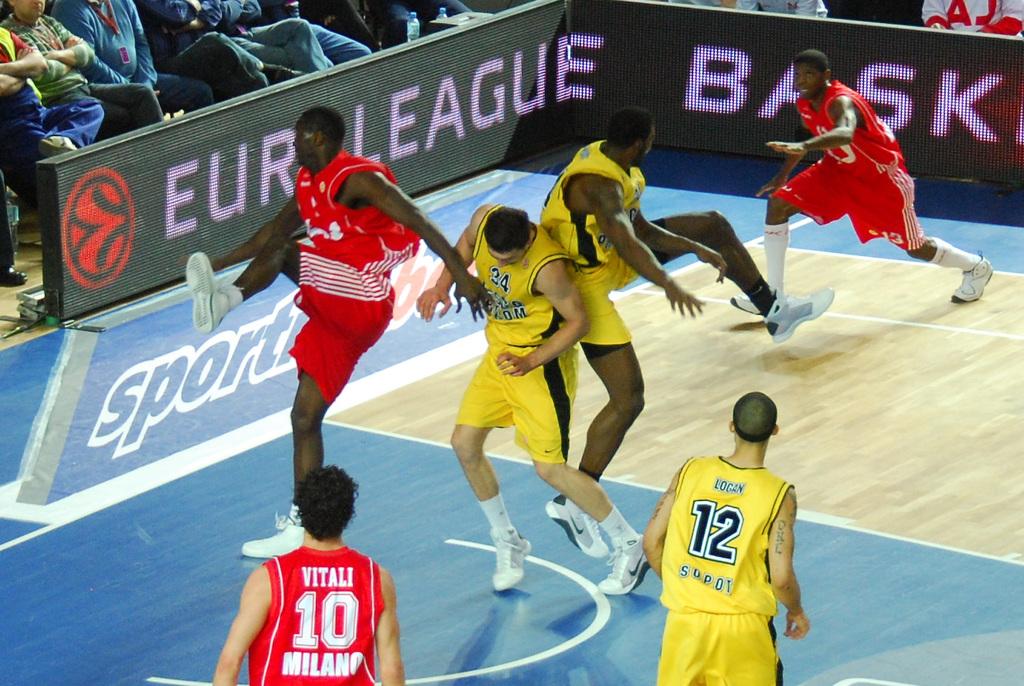What color is number 12's jersey?
Keep it short and to the point. Yellow. 